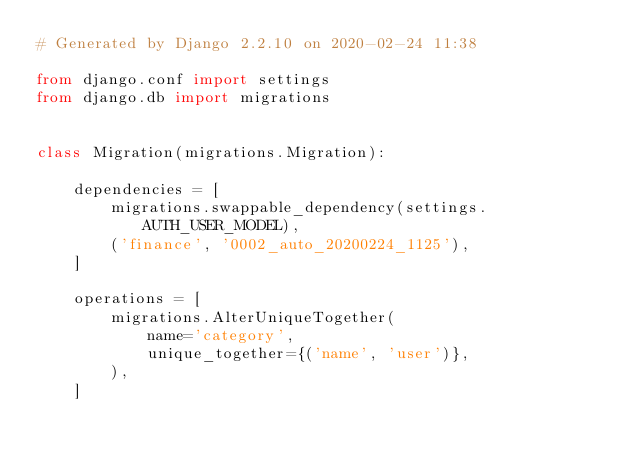<code> <loc_0><loc_0><loc_500><loc_500><_Python_># Generated by Django 2.2.10 on 2020-02-24 11:38

from django.conf import settings
from django.db import migrations


class Migration(migrations.Migration):

    dependencies = [
        migrations.swappable_dependency(settings.AUTH_USER_MODEL),
        ('finance', '0002_auto_20200224_1125'),
    ]

    operations = [
        migrations.AlterUniqueTogether(
            name='category',
            unique_together={('name', 'user')},
        ),
    ]
</code> 